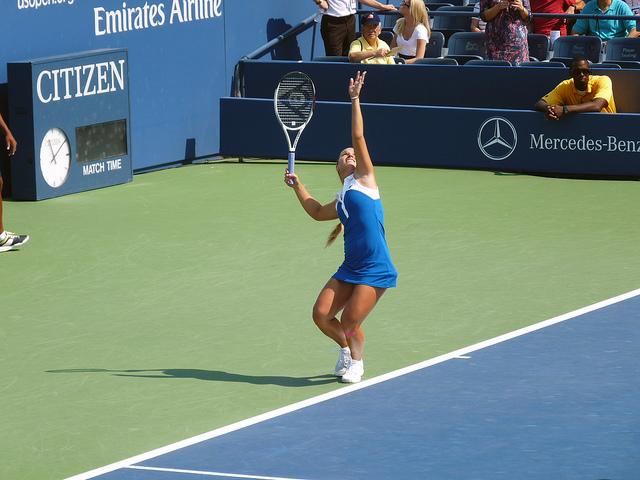What sport is this?
Write a very short answer. Tennis. What shot is this player hitting?
Keep it brief. Serve. What is the color of the woman's dress?
Answer briefly. Blue. What automobile company is a sponsor?
Write a very short answer. Mercedes-benz. What letter is on the racket?
Keep it brief. 0. 